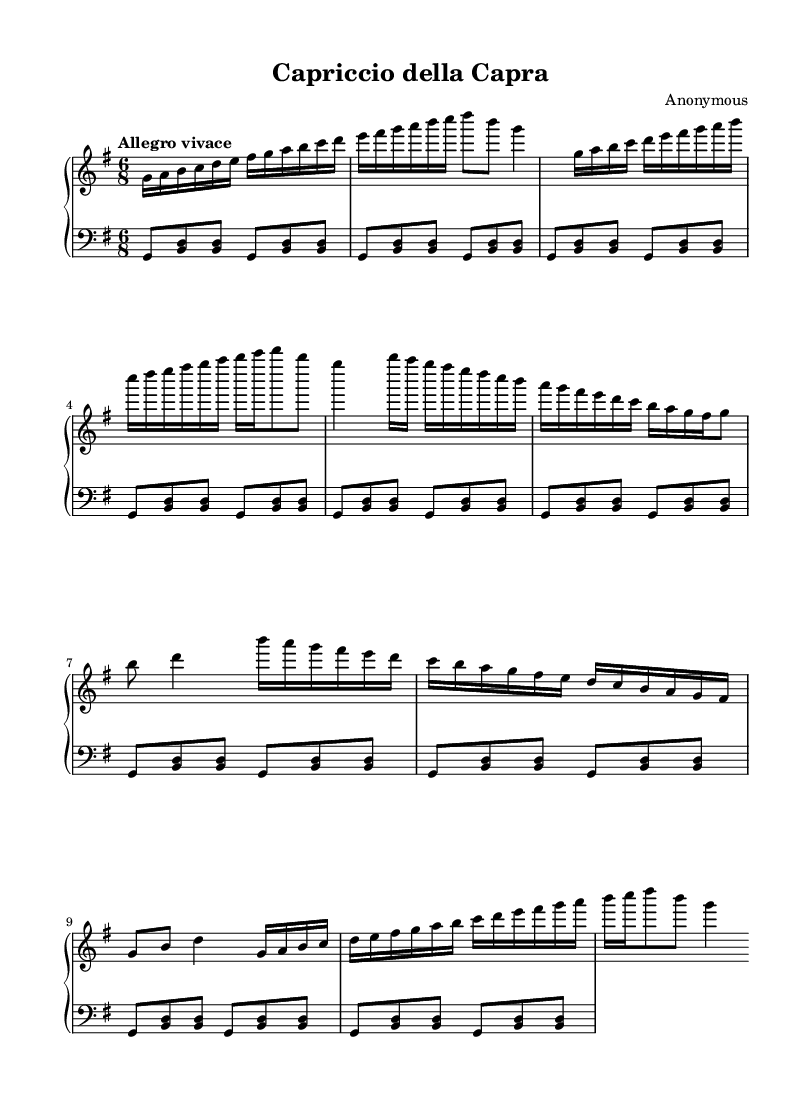What is the key signature of this music? The key signature is G major, which has one sharp (F#). This is indicated at the beginning of the staff.
Answer: G major What is the time signature of this piece? The time signature is 6/8, which can be seen at the beginning of the staff. It indicates a compound duple meter, typically felt as two beats per measure with a subdivision of three eighth notes per beat.
Answer: 6/8 What is the tempo marking for this piece? The tempo marking is "Allegro vivace," which suggests a lively and fast tempo. It is positioned above the staff, indicating how quickly the piece should be played.
Answer: Allegro vivace How many sections are in this piece? The piece consists of three sections: Section A, Section B, and Section A'. This can be determined by the distinct musical material that is repeated or varies throughout the work.
Answer: 3 Which hand plays the melodic material primarily? The right hand primarily plays the melodic material, as indicated by the higher pitch range and the types of notes written in the right staff. This includes the main themes and variations of the piece.
Answer: Right hand What is the rhythmic pattern for the left hand throughout? The left hand plays a repetitive pattern of eighth notes and chords (<b d>), establishing a harmonic foundation that accompanies the right hand's melody. The repetition of this pattern can be observed in the left staff throughout the piece.
Answer: Repetitive pattern 